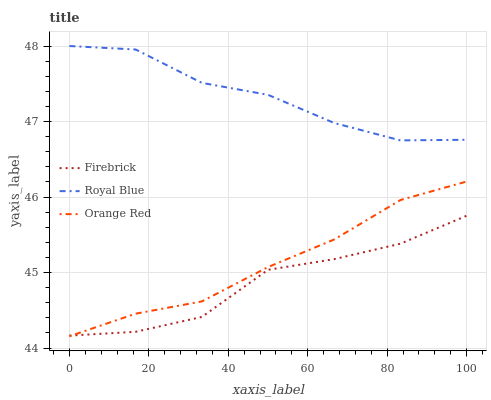Does Firebrick have the minimum area under the curve?
Answer yes or no. Yes. Does Royal Blue have the maximum area under the curve?
Answer yes or no. Yes. Does Orange Red have the minimum area under the curve?
Answer yes or no. No. Does Orange Red have the maximum area under the curve?
Answer yes or no. No. Is Orange Red the smoothest?
Answer yes or no. Yes. Is Firebrick the roughest?
Answer yes or no. Yes. Is Firebrick the smoothest?
Answer yes or no. No. Is Orange Red the roughest?
Answer yes or no. No. Does Orange Red have the lowest value?
Answer yes or no. Yes. Does Firebrick have the lowest value?
Answer yes or no. No. Does Royal Blue have the highest value?
Answer yes or no. Yes. Does Orange Red have the highest value?
Answer yes or no. No. Is Firebrick less than Royal Blue?
Answer yes or no. Yes. Is Royal Blue greater than Orange Red?
Answer yes or no. Yes. Does Orange Red intersect Firebrick?
Answer yes or no. Yes. Is Orange Red less than Firebrick?
Answer yes or no. No. Is Orange Red greater than Firebrick?
Answer yes or no. No. Does Firebrick intersect Royal Blue?
Answer yes or no. No. 